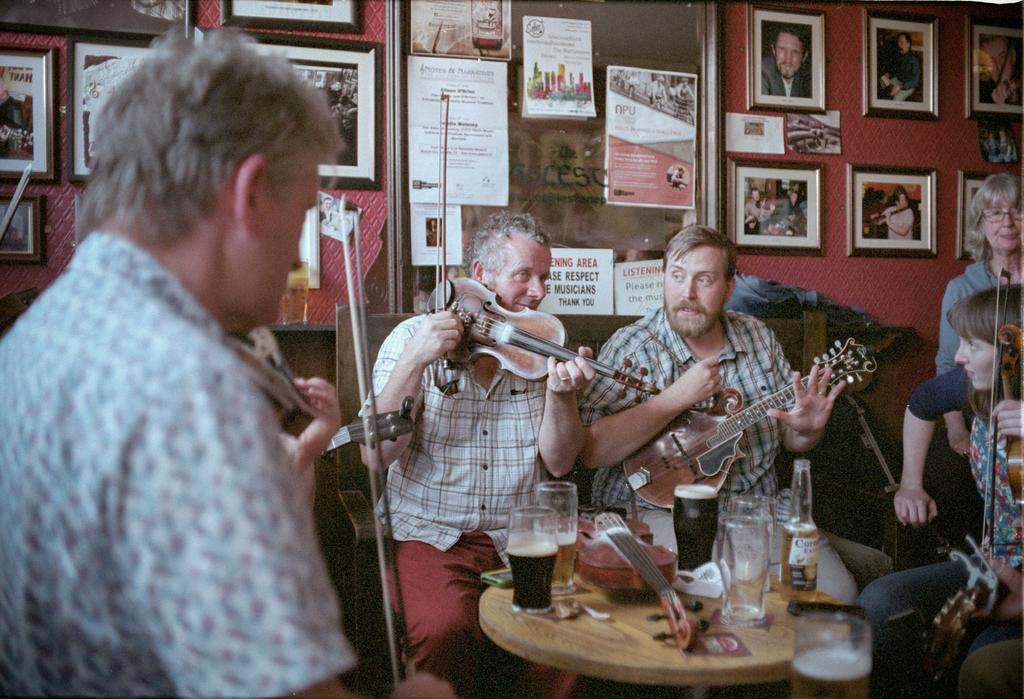What are the people in the image doing? The people in the image are playing violins. What is in front of the group of people? There is a table in front of the group of people. What can be seen on the table? There is a glass of drink on the table. What color is the vein of the daughter in the image? There is no daughter present in the image, and therefore no vein to describe. 